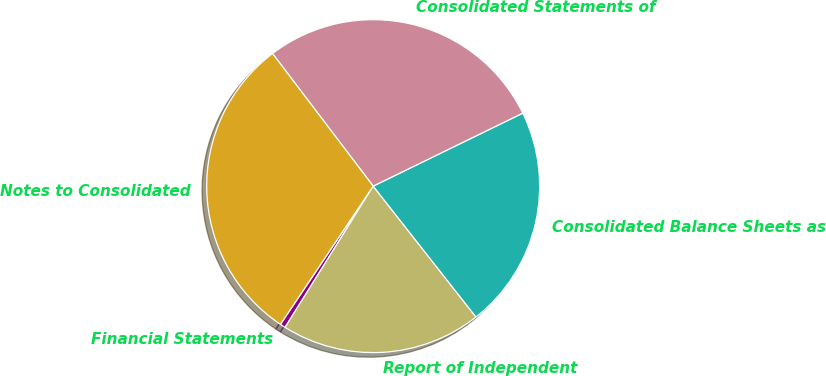Convert chart to OTSL. <chart><loc_0><loc_0><loc_500><loc_500><pie_chart><fcel>Financial Statements<fcel>Report of Independent<fcel>Consolidated Balance Sheets as<fcel>Consolidated Statements of<fcel>Notes to Consolidated<nl><fcel>0.53%<fcel>19.47%<fcel>21.63%<fcel>28.11%<fcel>30.26%<nl></chart> 